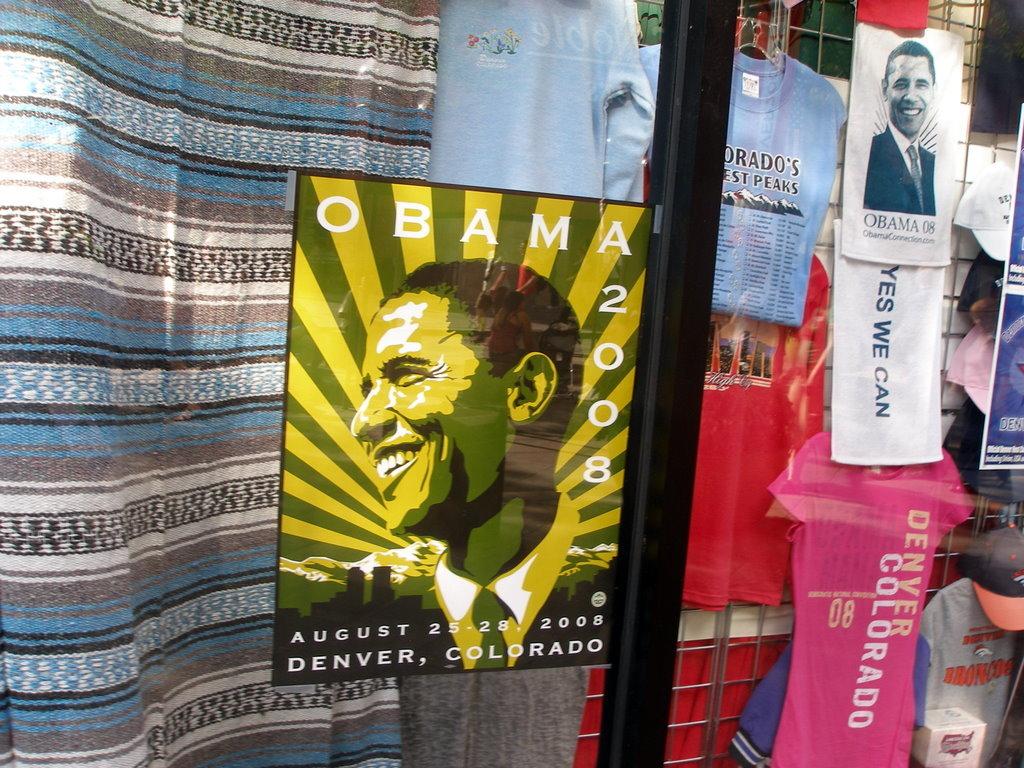Where was the even on august 25-28?
Provide a short and direct response. Denver, colorado. What is printed on the pink t-shirt?
Give a very brief answer. Denver colorado. 